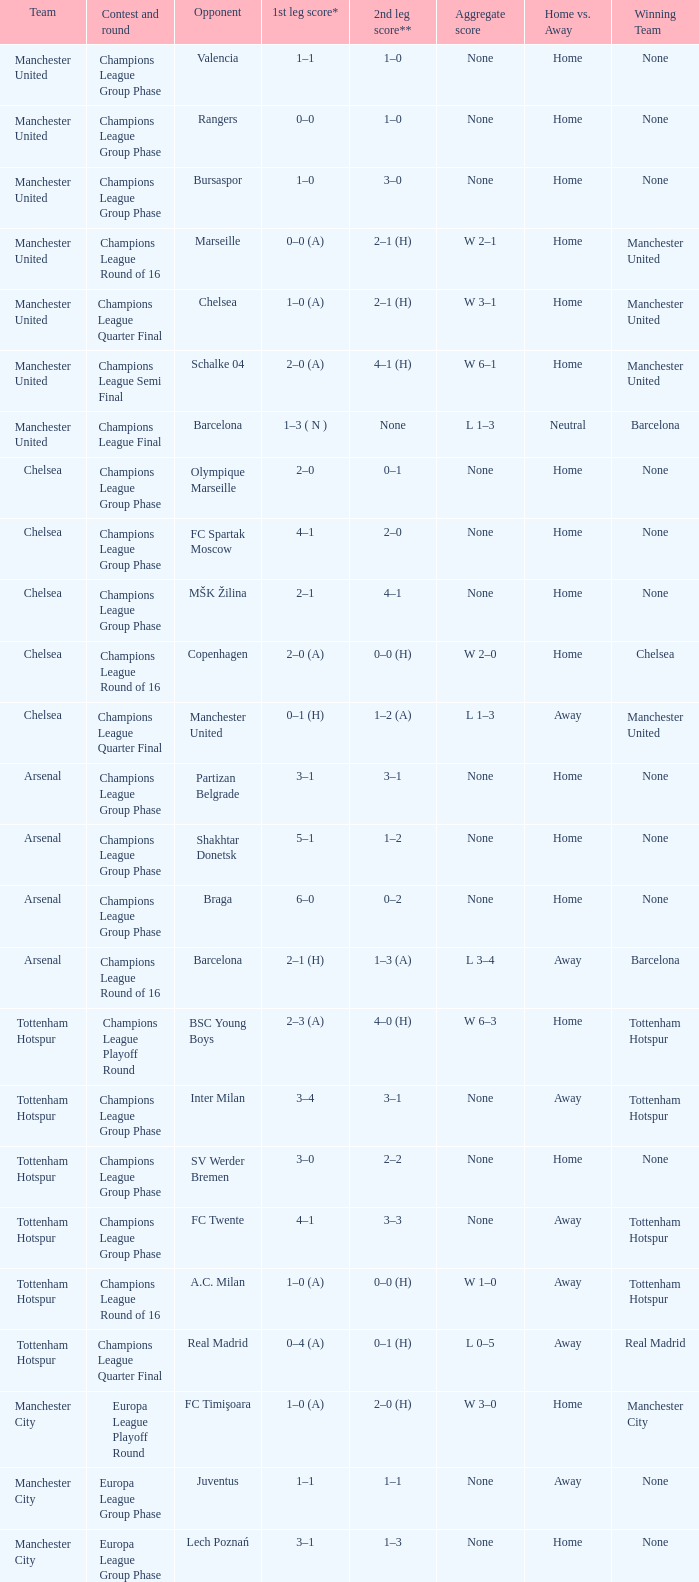How many goals did each team score in the first leg of the match between Liverpool and Steaua Bucureşti? 4–1. 